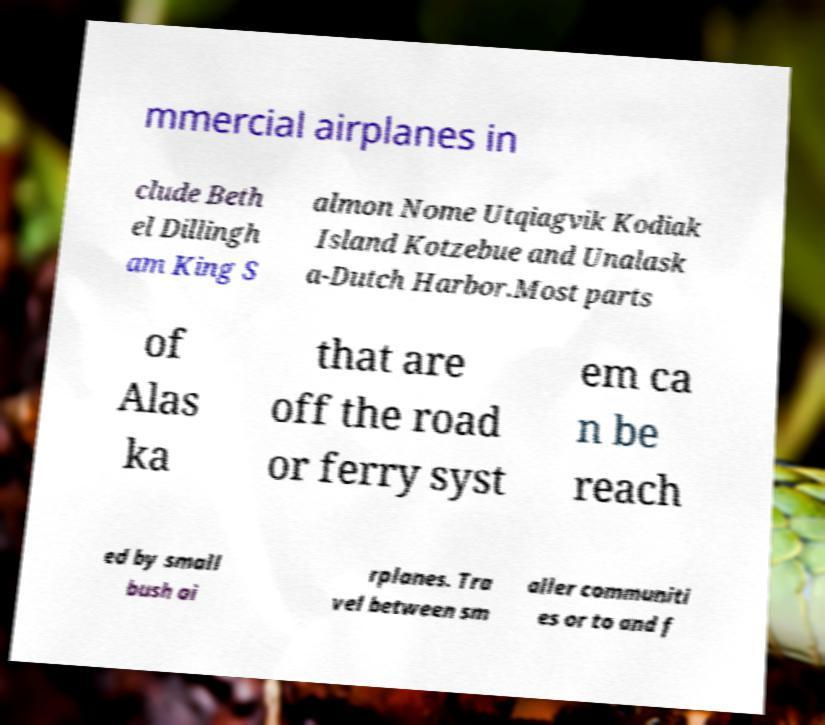Could you extract and type out the text from this image? mmercial airplanes in clude Beth el Dillingh am King S almon Nome Utqiagvik Kodiak Island Kotzebue and Unalask a-Dutch Harbor.Most parts of Alas ka that are off the road or ferry syst em ca n be reach ed by small bush ai rplanes. Tra vel between sm aller communiti es or to and f 